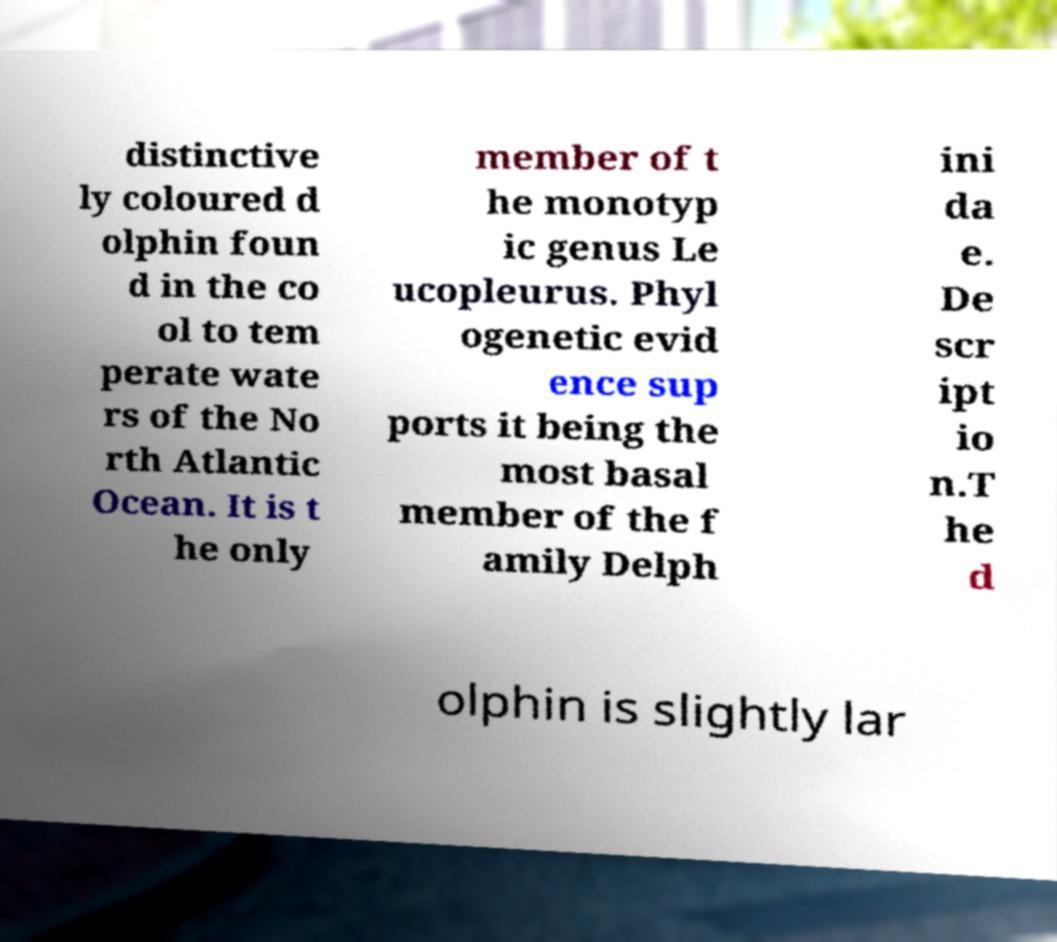I need the written content from this picture converted into text. Can you do that? distinctive ly coloured d olphin foun d in the co ol to tem perate wate rs of the No rth Atlantic Ocean. It is t he only member of t he monotyp ic genus Le ucopleurus. Phyl ogenetic evid ence sup ports it being the most basal member of the f amily Delph ini da e. De scr ipt io n.T he d olphin is slightly lar 